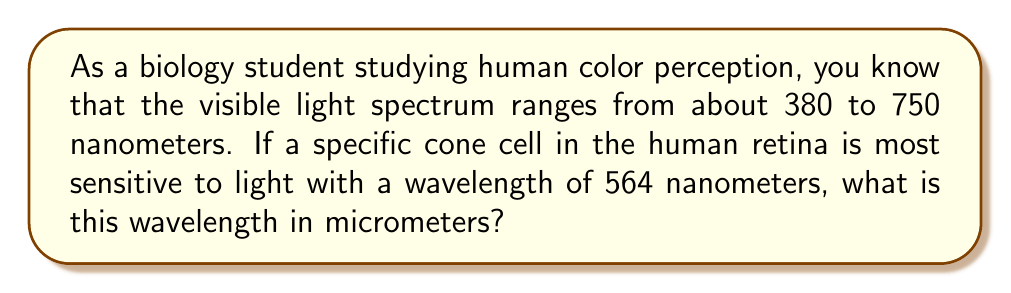Provide a solution to this math problem. To convert wavelengths from nanometers to micrometers, we need to understand the relationship between these units:

1) 1 micrometer (μm) = 1000 nanometers (nm)

To convert from nm to μm, we divide the number of nm by 1000:

$$ \text{Wavelength in μm} = \frac{\text{Wavelength in nm}}{1000} $$

For our specific problem:

$$ \text{Wavelength in μm} = \frac{564 \text{ nm}}{1000} $$

$$ = 0.564 \text{ μm} $$

This conversion is relevant to understanding the scale at which cone cells operate. The human eye has three types of cone cells, each sensitive to different wavelengths of light, which allows us to perceive different colors.
Answer: $0.564 \text{ μm}$ 